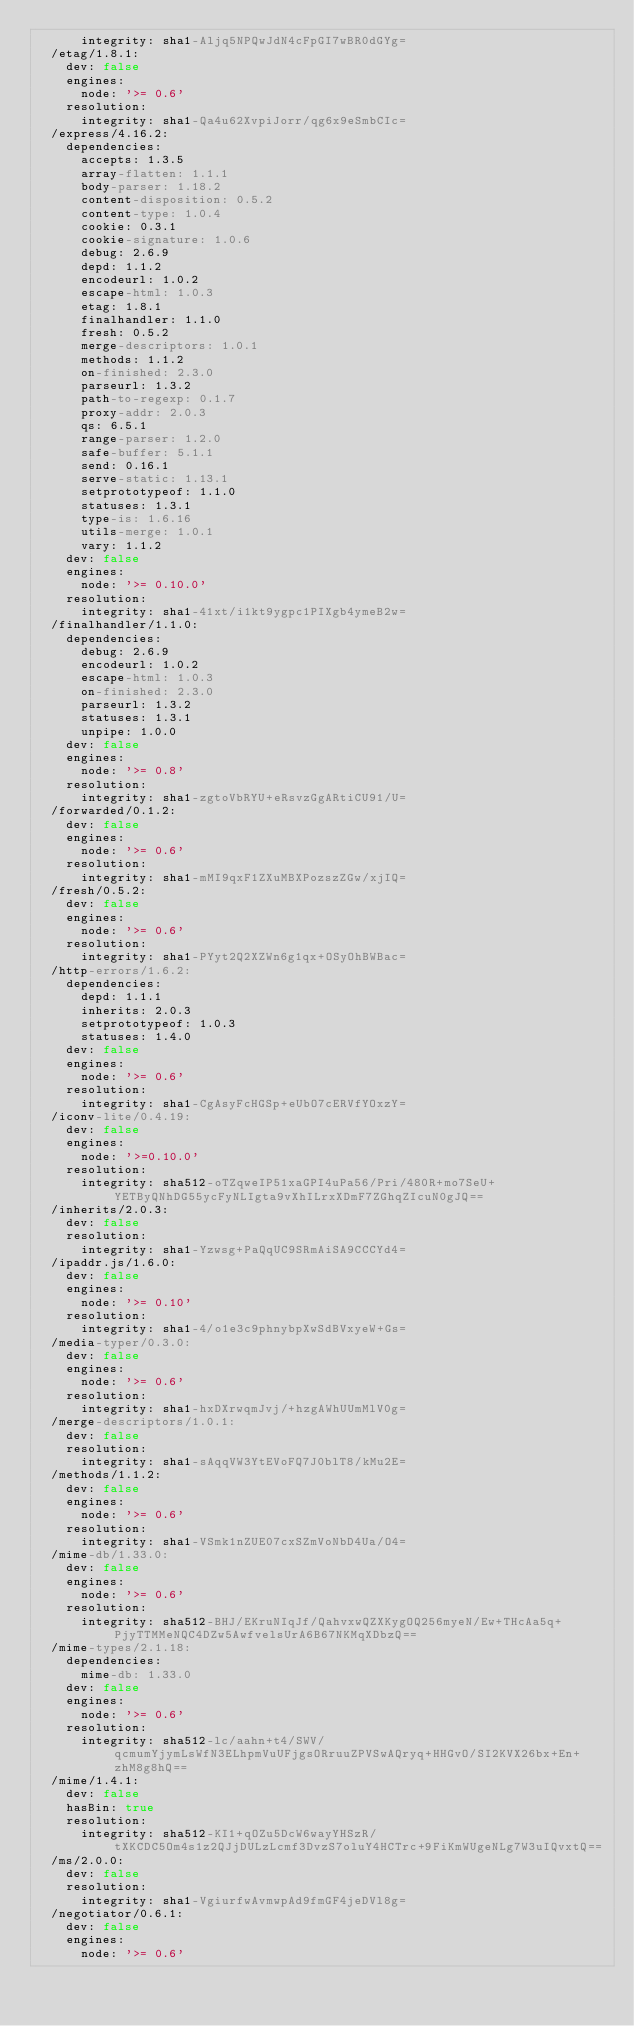<code> <loc_0><loc_0><loc_500><loc_500><_YAML_>      integrity: sha1-Aljq5NPQwJdN4cFpGI7wBR0dGYg=
  /etag/1.8.1:
    dev: false
    engines:
      node: '>= 0.6'
    resolution:
      integrity: sha1-Qa4u62XvpiJorr/qg6x9eSmbCIc=
  /express/4.16.2:
    dependencies:
      accepts: 1.3.5
      array-flatten: 1.1.1
      body-parser: 1.18.2
      content-disposition: 0.5.2
      content-type: 1.0.4
      cookie: 0.3.1
      cookie-signature: 1.0.6
      debug: 2.6.9
      depd: 1.1.2
      encodeurl: 1.0.2
      escape-html: 1.0.3
      etag: 1.8.1
      finalhandler: 1.1.0
      fresh: 0.5.2
      merge-descriptors: 1.0.1
      methods: 1.1.2
      on-finished: 2.3.0
      parseurl: 1.3.2
      path-to-regexp: 0.1.7
      proxy-addr: 2.0.3
      qs: 6.5.1
      range-parser: 1.2.0
      safe-buffer: 5.1.1
      send: 0.16.1
      serve-static: 1.13.1
      setprototypeof: 1.1.0
      statuses: 1.3.1
      type-is: 1.6.16
      utils-merge: 1.0.1
      vary: 1.1.2
    dev: false
    engines:
      node: '>= 0.10.0'
    resolution:
      integrity: sha1-41xt/i1kt9ygpc1PIXgb4ymeB2w=
  /finalhandler/1.1.0:
    dependencies:
      debug: 2.6.9
      encodeurl: 1.0.2
      escape-html: 1.0.3
      on-finished: 2.3.0
      parseurl: 1.3.2
      statuses: 1.3.1
      unpipe: 1.0.0
    dev: false
    engines:
      node: '>= 0.8'
    resolution:
      integrity: sha1-zgtoVbRYU+eRsvzGgARtiCU91/U=
  /forwarded/0.1.2:
    dev: false
    engines:
      node: '>= 0.6'
    resolution:
      integrity: sha1-mMI9qxF1ZXuMBXPozszZGw/xjIQ=
  /fresh/0.5.2:
    dev: false
    engines:
      node: '>= 0.6'
    resolution:
      integrity: sha1-PYyt2Q2XZWn6g1qx+OSyOhBWBac=
  /http-errors/1.6.2:
    dependencies:
      depd: 1.1.1
      inherits: 2.0.3
      setprototypeof: 1.0.3
      statuses: 1.4.0
    dev: false
    engines:
      node: '>= 0.6'
    resolution:
      integrity: sha1-CgAsyFcHGSp+eUbO7cERVfYOxzY=
  /iconv-lite/0.4.19:
    dev: false
    engines:
      node: '>=0.10.0'
    resolution:
      integrity: sha512-oTZqweIP51xaGPI4uPa56/Pri/480R+mo7SeU+YETByQNhDG55ycFyNLIgta9vXhILrxXDmF7ZGhqZIcuN0gJQ==
  /inherits/2.0.3:
    dev: false
    resolution:
      integrity: sha1-Yzwsg+PaQqUC9SRmAiSA9CCCYd4=
  /ipaddr.js/1.6.0:
    dev: false
    engines:
      node: '>= 0.10'
    resolution:
      integrity: sha1-4/o1e3c9phnybpXwSdBVxyeW+Gs=
  /media-typer/0.3.0:
    dev: false
    engines:
      node: '>= 0.6'
    resolution:
      integrity: sha1-hxDXrwqmJvj/+hzgAWhUUmMlV0g=
  /merge-descriptors/1.0.1:
    dev: false
    resolution:
      integrity: sha1-sAqqVW3YtEVoFQ7J0blT8/kMu2E=
  /methods/1.1.2:
    dev: false
    engines:
      node: '>= 0.6'
    resolution:
      integrity: sha1-VSmk1nZUE07cxSZmVoNbD4Ua/O4=
  /mime-db/1.33.0:
    dev: false
    engines:
      node: '>= 0.6'
    resolution:
      integrity: sha512-BHJ/EKruNIqJf/QahvxwQZXKygOQ256myeN/Ew+THcAa5q+PjyTTMMeNQC4DZw5AwfvelsUrA6B67NKMqXDbzQ==
  /mime-types/2.1.18:
    dependencies:
      mime-db: 1.33.0
    dev: false
    engines:
      node: '>= 0.6'
    resolution:
      integrity: sha512-lc/aahn+t4/SWV/qcmumYjymLsWfN3ELhpmVuUFjgsORruuZPVSwAQryq+HHGvO/SI2KVX26bx+En+zhM8g8hQ==
  /mime/1.4.1:
    dev: false
    hasBin: true
    resolution:
      integrity: sha512-KI1+qOZu5DcW6wayYHSzR/tXKCDC5Om4s1z2QJjDULzLcmf3DvzS7oluY4HCTrc+9FiKmWUgeNLg7W3uIQvxtQ==
  /ms/2.0.0:
    dev: false
    resolution:
      integrity: sha1-VgiurfwAvmwpAd9fmGF4jeDVl8g=
  /negotiator/0.6.1:
    dev: false
    engines:
      node: '>= 0.6'</code> 